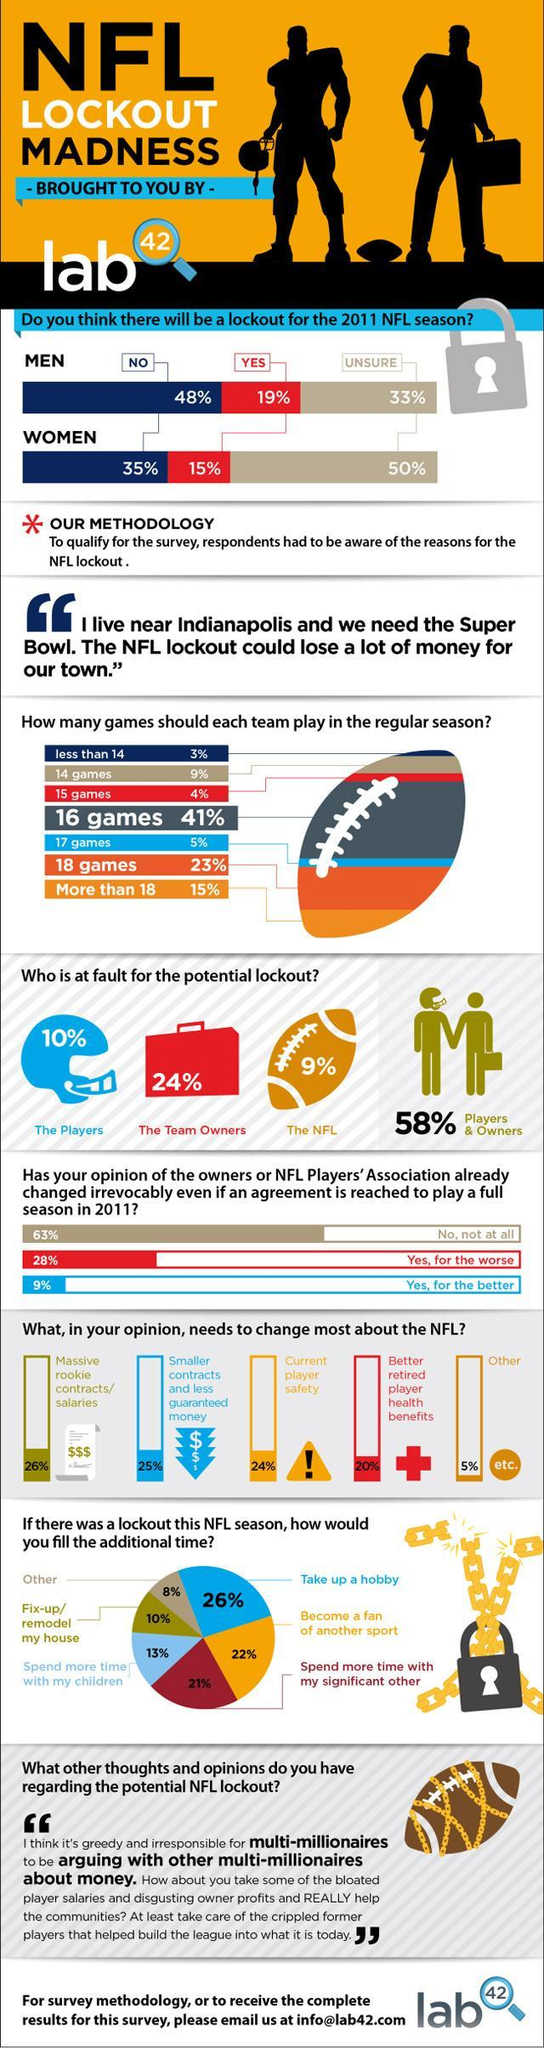What percentage of respondents think that it is the fault of the players & owners that will lead to a lockout in the 2011 NFL season as per the survey?
Answer the question with a short phrase. 58% What percentage of respondents think that each team should play more than 18 games in the regular NFL season according to the survey? 15% How many games each team should play in the regular NFL season according to the majority of the respondents of the survey? 16 games What percentage of respondents think that it is the fault of the team owners that will lead to a lockout in the 2011 NFL season according to the survey? 24% What do the majority of the respondents do if there was a lockout for this NFL season according to the survey? Take up a hobby What percent of women are unsure about the lockout for the 2011 NFL season according to the survey? 50% What percent of men think that there will be a lockout for the 2011 NFL season according to the survey? 19% What percentage of respondents felt that there should be a better retired player health benefits for the NFL according to the survey? 20% What percent of men are unsure about the lockout for the 2011 NFL season according to the survey? 33% 